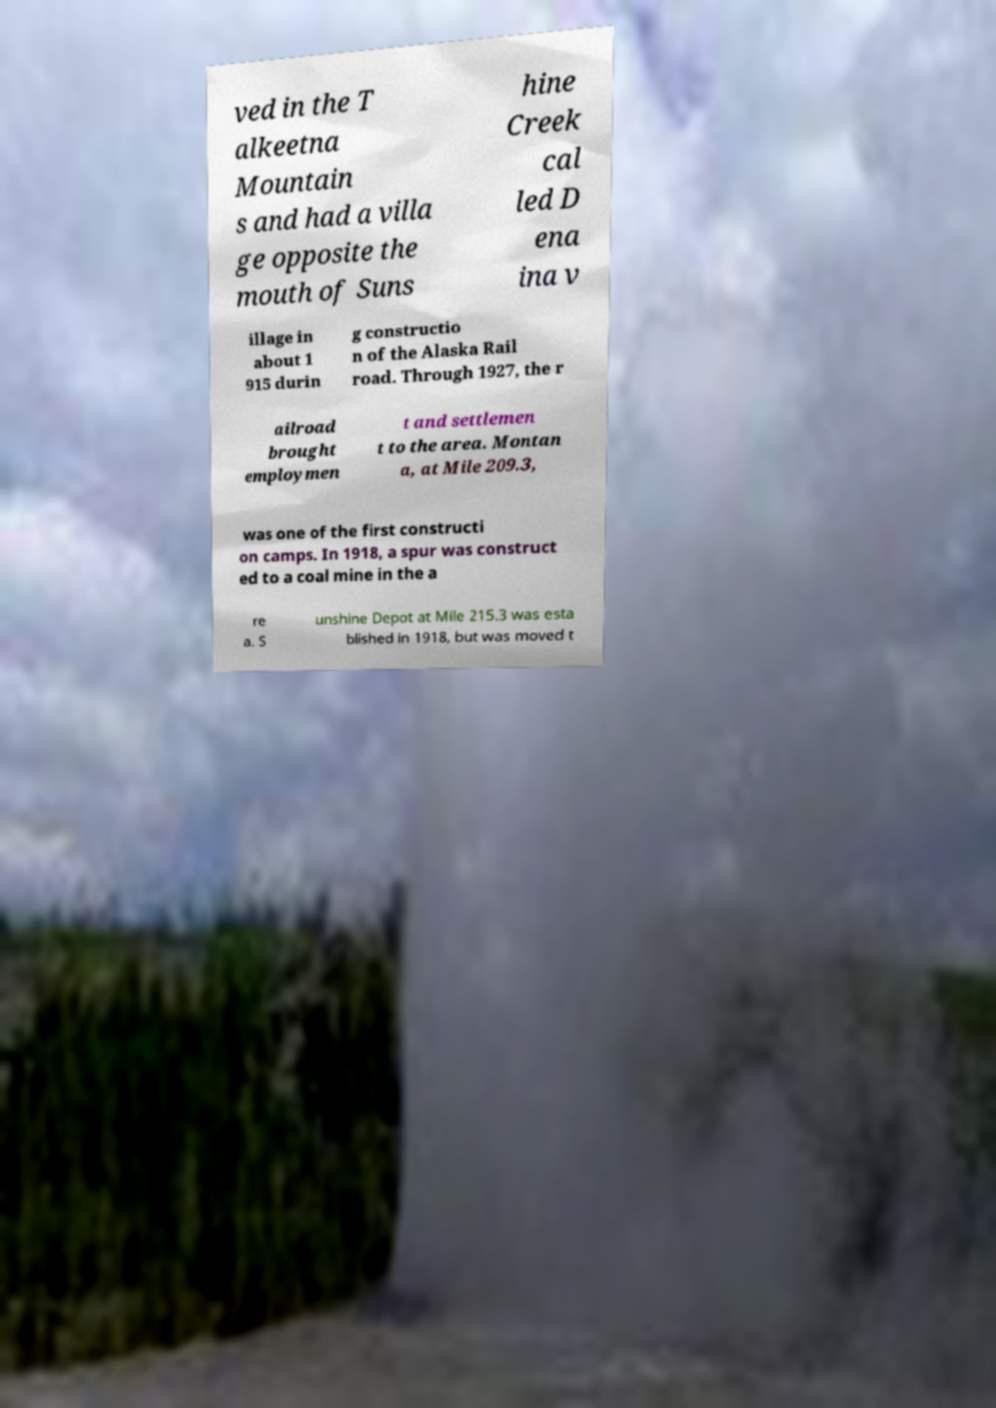What messages or text are displayed in this image? I need them in a readable, typed format. ved in the T alkeetna Mountain s and had a villa ge opposite the mouth of Suns hine Creek cal led D ena ina v illage in about 1 915 durin g constructio n of the Alaska Rail road. Through 1927, the r ailroad brought employmen t and settlemen t to the area. Montan a, at Mile 209.3, was one of the first constructi on camps. In 1918, a spur was construct ed to a coal mine in the a re a. S unshine Depot at Mile 215.3 was esta blished in 1918, but was moved t 